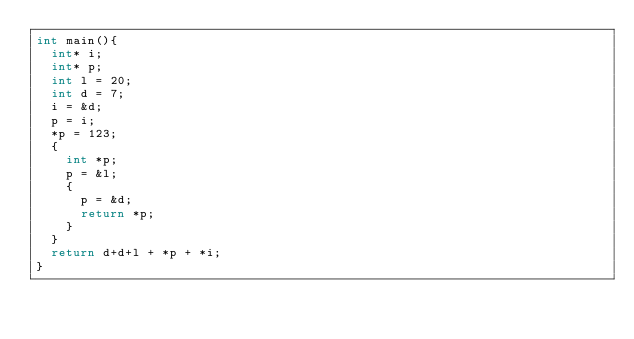<code> <loc_0><loc_0><loc_500><loc_500><_C_>int main(){
  int* i;
  int* p;
  int l = 20;
  int d = 7;
  i = &d;
  p = i;
  *p = 123;
  {
    int *p;
    p = &l;
    {
      p = &d;
      return *p;
    }
  }
  return d+d+l + *p + *i;
}
</code> 